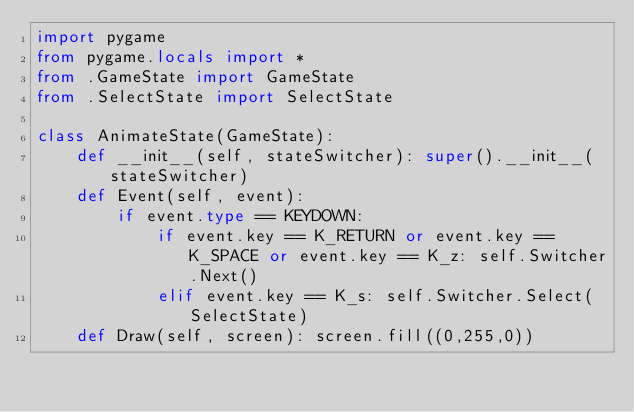Convert code to text. <code><loc_0><loc_0><loc_500><loc_500><_Python_>import pygame
from pygame.locals import *
from .GameState import GameState
from .SelectState import SelectState

class AnimateState(GameState):
    def __init__(self, stateSwitcher): super().__init__(stateSwitcher)
    def Event(self, event):
        if event.type == KEYDOWN:
            if event.key == K_RETURN or event.key == K_SPACE or event.key == K_z: self.Switcher.Next()
            elif event.key == K_s: self.Switcher.Select(SelectState)
    def Draw(self, screen): screen.fill((0,255,0))
</code> 